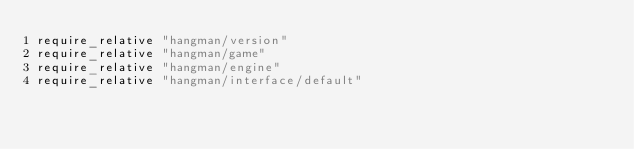Convert code to text. <code><loc_0><loc_0><loc_500><loc_500><_Ruby_>require_relative "hangman/version"
require_relative "hangman/game"
require_relative "hangman/engine"
require_relative "hangman/interface/default"
</code> 